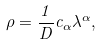<formula> <loc_0><loc_0><loc_500><loc_500>\rho = \frac { 1 } { D } c _ { \alpha } \lambda ^ { \alpha } ,</formula> 